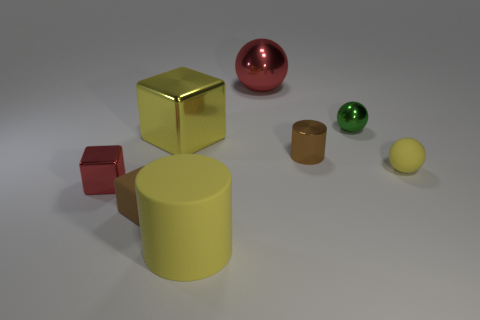Add 1 metallic blocks. How many objects exist? 9 Subtract all cylinders. How many objects are left? 6 Subtract all small green metallic things. Subtract all yellow matte things. How many objects are left? 5 Add 7 rubber things. How many rubber things are left? 10 Add 7 tiny red blocks. How many tiny red blocks exist? 8 Subtract 1 yellow cylinders. How many objects are left? 7 